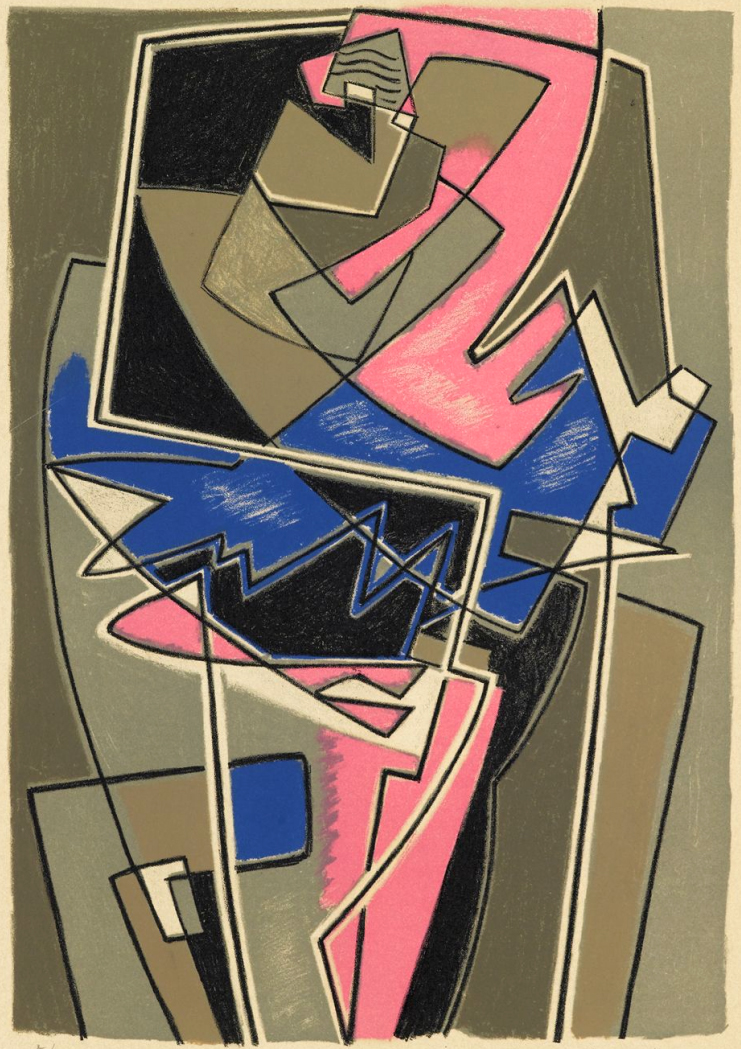Can you describe the emotions this abstract piece might evoke in a viewer? The abstract nature of this piece can evoke a myriad of emotions, depending on the viewer’s personal interpretation and mood. The sharp contrasts and vibrant hues of pink and blue against the muted background can evoke feelings of excitement, vibrancy, and modernism. The geometric complexity might provoke curiosity and intrigue, inviting the viewer to discern patterns or meanings within the chaotic arrangement. For some, the angular intersections and overlapping shapes might also evoke a sense of tension or conflict, while others might find a harmonious balance in the seeming disorder. Overall, the piece is likely to spark a thoughtful and emotional response, prompting viewers to engage deeply with the art. What could this artwork symbolize about human experience? This artwork might symbolize the multifaceted nature of the human experience. The overlapping shapes and intersecting lines can represent the complexities and interconnected aspects of life's many facets. The vibrant colors could symbolize the various emotions and energies that we encounter, while the use of geometric forms might illustrate how we try to impose structure and logic on our often chaotic lives. The sense of depth and layering in the composition might further symbolize the layers of our experiences and personalities, suggesting that beneath the surface of our daily existence lies a rich and intricate web of experiences, emotions, and interactions. Imagine this artwork is a portal to another dimension. Describe that dimension. Stepping through the artwork, you find yourself in a dimension where geometry governs all aspects of reality. This world is an endless expanse of structured yet dynamic space, where the ground, sky, and everything in between are composed of intersecting planes and sharp angles in vibrant colors. The atmosphere is a shifting palette of hues, constantly changing, generated by the interactions of floating geometric forms. Gravity here is fluid, sometimes letting you float in zero-g space while at other moments grounding you firmly on a crisscrossed plane of triangles and squares. The inhabitants of this dimension are abstract entities — beings composed of shapes and colors that communicate through the expressive manipulation of their forms. This world is a living abstract artwork, a testament to the harmony and chaos inherent in geometric beauty. How would you interpret the use of color in this piece in a real-world scenario? In a real-world scenario, the use of color in this piece might be seen as a strategic tool for conveying specific emotions or themes. The contrast between the bold pink and blue against the muted black and gray could be interpreted as a representation of the interplay between vibrancy and monotony, life and stillness. This could translate to everyday experiences where moments of emotional intensity and vitality stand out against the backdrop of routine and formality. The artist might be using these colors to draw attention to the most dynamic parts of the composition, suggesting that even within the structured confines of our lives, there are bursts of passion, creativity, and change. Can you summarize the overall aesthetic of this artwork in a sentence? The overall aesthetic of this artwork is a harmonious balance of chaos and order, achieved through the dynamic interplay of geometric forms and contrasting colors, reflecting the complexity and vibrancy of abstract art. 